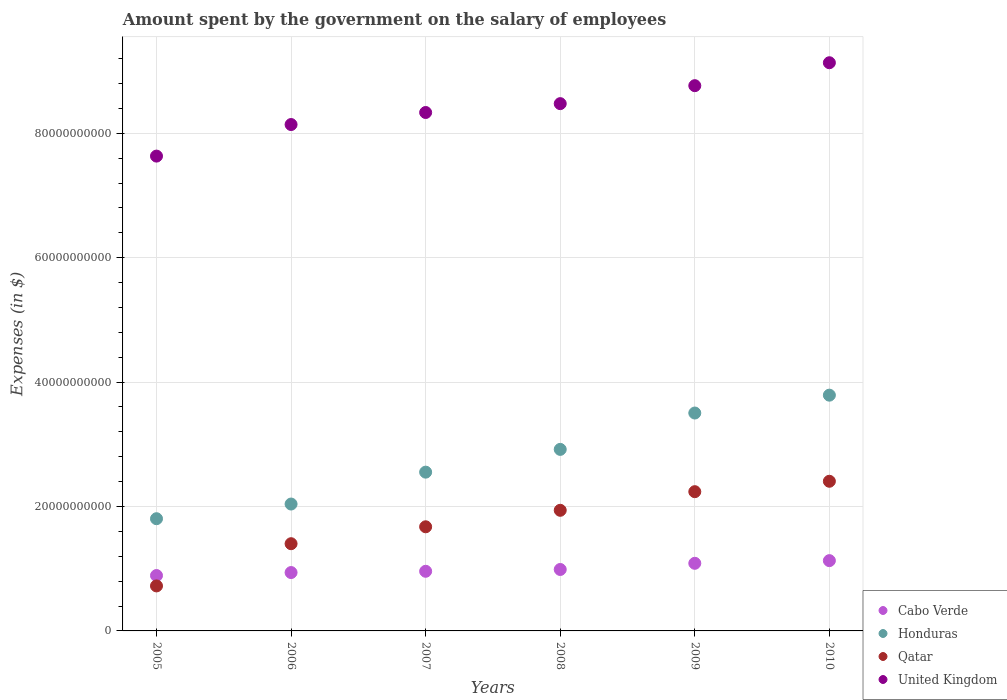How many different coloured dotlines are there?
Give a very brief answer. 4. Is the number of dotlines equal to the number of legend labels?
Provide a succinct answer. Yes. What is the amount spent on the salary of employees by the government in Qatar in 2008?
Ensure brevity in your answer.  1.94e+1. Across all years, what is the maximum amount spent on the salary of employees by the government in Qatar?
Provide a succinct answer. 2.41e+1. Across all years, what is the minimum amount spent on the salary of employees by the government in Honduras?
Your response must be concise. 1.80e+1. What is the total amount spent on the salary of employees by the government in Qatar in the graph?
Provide a short and direct response. 1.04e+11. What is the difference between the amount spent on the salary of employees by the government in Qatar in 2009 and that in 2010?
Keep it short and to the point. -1.67e+09. What is the difference between the amount spent on the salary of employees by the government in United Kingdom in 2007 and the amount spent on the salary of employees by the government in Honduras in 2010?
Give a very brief answer. 4.54e+1. What is the average amount spent on the salary of employees by the government in Qatar per year?
Your response must be concise. 1.73e+1. In the year 2006, what is the difference between the amount spent on the salary of employees by the government in Honduras and amount spent on the salary of employees by the government in Qatar?
Ensure brevity in your answer.  6.38e+09. What is the ratio of the amount spent on the salary of employees by the government in Cabo Verde in 2006 to that in 2008?
Make the answer very short. 0.95. Is the difference between the amount spent on the salary of employees by the government in Honduras in 2005 and 2006 greater than the difference between the amount spent on the salary of employees by the government in Qatar in 2005 and 2006?
Provide a succinct answer. Yes. What is the difference between the highest and the second highest amount spent on the salary of employees by the government in Honduras?
Offer a very short reply. 2.87e+09. What is the difference between the highest and the lowest amount spent on the salary of employees by the government in Qatar?
Ensure brevity in your answer.  1.68e+1. Is it the case that in every year, the sum of the amount spent on the salary of employees by the government in Cabo Verde and amount spent on the salary of employees by the government in United Kingdom  is greater than the amount spent on the salary of employees by the government in Qatar?
Offer a terse response. Yes. Does the amount spent on the salary of employees by the government in Qatar monotonically increase over the years?
Your answer should be very brief. Yes. How many years are there in the graph?
Offer a very short reply. 6. Where does the legend appear in the graph?
Offer a very short reply. Bottom right. What is the title of the graph?
Your response must be concise. Amount spent by the government on the salary of employees. Does "World" appear as one of the legend labels in the graph?
Offer a very short reply. No. What is the label or title of the X-axis?
Provide a succinct answer. Years. What is the label or title of the Y-axis?
Provide a succinct answer. Expenses (in $). What is the Expenses (in $) in Cabo Verde in 2005?
Offer a very short reply. 8.90e+09. What is the Expenses (in $) of Honduras in 2005?
Your answer should be very brief. 1.80e+1. What is the Expenses (in $) in Qatar in 2005?
Your answer should be compact. 7.23e+09. What is the Expenses (in $) of United Kingdom in 2005?
Make the answer very short. 7.63e+1. What is the Expenses (in $) of Cabo Verde in 2006?
Provide a succinct answer. 9.38e+09. What is the Expenses (in $) of Honduras in 2006?
Provide a short and direct response. 2.04e+1. What is the Expenses (in $) in Qatar in 2006?
Make the answer very short. 1.40e+1. What is the Expenses (in $) of United Kingdom in 2006?
Provide a succinct answer. 8.14e+1. What is the Expenses (in $) in Cabo Verde in 2007?
Offer a terse response. 9.59e+09. What is the Expenses (in $) of Honduras in 2007?
Offer a terse response. 2.55e+1. What is the Expenses (in $) of Qatar in 2007?
Your answer should be compact. 1.67e+1. What is the Expenses (in $) in United Kingdom in 2007?
Keep it short and to the point. 8.33e+1. What is the Expenses (in $) of Cabo Verde in 2008?
Your answer should be compact. 9.88e+09. What is the Expenses (in $) of Honduras in 2008?
Provide a short and direct response. 2.92e+1. What is the Expenses (in $) in Qatar in 2008?
Your response must be concise. 1.94e+1. What is the Expenses (in $) of United Kingdom in 2008?
Give a very brief answer. 8.48e+1. What is the Expenses (in $) of Cabo Verde in 2009?
Keep it short and to the point. 1.09e+1. What is the Expenses (in $) of Honduras in 2009?
Your answer should be compact. 3.50e+1. What is the Expenses (in $) of Qatar in 2009?
Your answer should be compact. 2.24e+1. What is the Expenses (in $) in United Kingdom in 2009?
Your answer should be compact. 8.77e+1. What is the Expenses (in $) in Cabo Verde in 2010?
Provide a short and direct response. 1.13e+1. What is the Expenses (in $) of Honduras in 2010?
Your response must be concise. 3.79e+1. What is the Expenses (in $) of Qatar in 2010?
Your answer should be very brief. 2.41e+1. What is the Expenses (in $) of United Kingdom in 2010?
Make the answer very short. 9.13e+1. Across all years, what is the maximum Expenses (in $) of Cabo Verde?
Keep it short and to the point. 1.13e+1. Across all years, what is the maximum Expenses (in $) of Honduras?
Give a very brief answer. 3.79e+1. Across all years, what is the maximum Expenses (in $) of Qatar?
Provide a short and direct response. 2.41e+1. Across all years, what is the maximum Expenses (in $) of United Kingdom?
Keep it short and to the point. 9.13e+1. Across all years, what is the minimum Expenses (in $) of Cabo Verde?
Your response must be concise. 8.90e+09. Across all years, what is the minimum Expenses (in $) in Honduras?
Offer a very short reply. 1.80e+1. Across all years, what is the minimum Expenses (in $) of Qatar?
Make the answer very short. 7.23e+09. Across all years, what is the minimum Expenses (in $) in United Kingdom?
Make the answer very short. 7.63e+1. What is the total Expenses (in $) of Cabo Verde in the graph?
Provide a succinct answer. 5.99e+1. What is the total Expenses (in $) in Honduras in the graph?
Make the answer very short. 1.66e+11. What is the total Expenses (in $) in Qatar in the graph?
Offer a very short reply. 1.04e+11. What is the total Expenses (in $) in United Kingdom in the graph?
Keep it short and to the point. 5.05e+11. What is the difference between the Expenses (in $) in Cabo Verde in 2005 and that in 2006?
Provide a succinct answer. -4.81e+08. What is the difference between the Expenses (in $) of Honduras in 2005 and that in 2006?
Ensure brevity in your answer.  -2.36e+09. What is the difference between the Expenses (in $) in Qatar in 2005 and that in 2006?
Offer a terse response. -6.79e+09. What is the difference between the Expenses (in $) in United Kingdom in 2005 and that in 2006?
Provide a succinct answer. -5.07e+09. What is the difference between the Expenses (in $) of Cabo Verde in 2005 and that in 2007?
Keep it short and to the point. -6.84e+08. What is the difference between the Expenses (in $) in Honduras in 2005 and that in 2007?
Ensure brevity in your answer.  -7.49e+09. What is the difference between the Expenses (in $) of Qatar in 2005 and that in 2007?
Give a very brief answer. -9.51e+09. What is the difference between the Expenses (in $) of United Kingdom in 2005 and that in 2007?
Provide a short and direct response. -7.01e+09. What is the difference between the Expenses (in $) in Cabo Verde in 2005 and that in 2008?
Your answer should be very brief. -9.74e+08. What is the difference between the Expenses (in $) in Honduras in 2005 and that in 2008?
Ensure brevity in your answer.  -1.11e+1. What is the difference between the Expenses (in $) of Qatar in 2005 and that in 2008?
Provide a succinct answer. -1.22e+1. What is the difference between the Expenses (in $) in United Kingdom in 2005 and that in 2008?
Offer a terse response. -8.43e+09. What is the difference between the Expenses (in $) of Cabo Verde in 2005 and that in 2009?
Your answer should be very brief. -1.97e+09. What is the difference between the Expenses (in $) in Honduras in 2005 and that in 2009?
Provide a short and direct response. -1.70e+1. What is the difference between the Expenses (in $) of Qatar in 2005 and that in 2009?
Provide a short and direct response. -1.52e+1. What is the difference between the Expenses (in $) in United Kingdom in 2005 and that in 2009?
Offer a terse response. -1.13e+1. What is the difference between the Expenses (in $) of Cabo Verde in 2005 and that in 2010?
Offer a very short reply. -2.39e+09. What is the difference between the Expenses (in $) in Honduras in 2005 and that in 2010?
Keep it short and to the point. -1.99e+1. What is the difference between the Expenses (in $) in Qatar in 2005 and that in 2010?
Your answer should be very brief. -1.68e+1. What is the difference between the Expenses (in $) of United Kingdom in 2005 and that in 2010?
Offer a very short reply. -1.50e+1. What is the difference between the Expenses (in $) in Cabo Verde in 2006 and that in 2007?
Your answer should be compact. -2.03e+08. What is the difference between the Expenses (in $) in Honduras in 2006 and that in 2007?
Provide a short and direct response. -5.13e+09. What is the difference between the Expenses (in $) of Qatar in 2006 and that in 2007?
Offer a very short reply. -2.72e+09. What is the difference between the Expenses (in $) of United Kingdom in 2006 and that in 2007?
Your answer should be very brief. -1.94e+09. What is the difference between the Expenses (in $) of Cabo Verde in 2006 and that in 2008?
Your answer should be very brief. -4.93e+08. What is the difference between the Expenses (in $) of Honduras in 2006 and that in 2008?
Offer a very short reply. -8.79e+09. What is the difference between the Expenses (in $) of Qatar in 2006 and that in 2008?
Give a very brief answer. -5.37e+09. What is the difference between the Expenses (in $) of United Kingdom in 2006 and that in 2008?
Provide a succinct answer. -3.36e+09. What is the difference between the Expenses (in $) in Cabo Verde in 2006 and that in 2009?
Your response must be concise. -1.49e+09. What is the difference between the Expenses (in $) in Honduras in 2006 and that in 2009?
Your answer should be very brief. -1.46e+1. What is the difference between the Expenses (in $) of Qatar in 2006 and that in 2009?
Ensure brevity in your answer.  -8.36e+09. What is the difference between the Expenses (in $) in United Kingdom in 2006 and that in 2009?
Give a very brief answer. -6.25e+09. What is the difference between the Expenses (in $) in Cabo Verde in 2006 and that in 2010?
Provide a succinct answer. -1.91e+09. What is the difference between the Expenses (in $) in Honduras in 2006 and that in 2010?
Provide a short and direct response. -1.75e+1. What is the difference between the Expenses (in $) in Qatar in 2006 and that in 2010?
Your answer should be very brief. -1.00e+1. What is the difference between the Expenses (in $) of United Kingdom in 2006 and that in 2010?
Make the answer very short. -9.94e+09. What is the difference between the Expenses (in $) of Cabo Verde in 2007 and that in 2008?
Offer a very short reply. -2.90e+08. What is the difference between the Expenses (in $) in Honduras in 2007 and that in 2008?
Provide a short and direct response. -3.66e+09. What is the difference between the Expenses (in $) of Qatar in 2007 and that in 2008?
Your answer should be very brief. -2.65e+09. What is the difference between the Expenses (in $) of United Kingdom in 2007 and that in 2008?
Provide a succinct answer. -1.42e+09. What is the difference between the Expenses (in $) of Cabo Verde in 2007 and that in 2009?
Give a very brief answer. -1.28e+09. What is the difference between the Expenses (in $) in Honduras in 2007 and that in 2009?
Provide a short and direct response. -9.50e+09. What is the difference between the Expenses (in $) of Qatar in 2007 and that in 2009?
Make the answer very short. -5.64e+09. What is the difference between the Expenses (in $) of United Kingdom in 2007 and that in 2009?
Your answer should be very brief. -4.31e+09. What is the difference between the Expenses (in $) in Cabo Verde in 2007 and that in 2010?
Your response must be concise. -1.71e+09. What is the difference between the Expenses (in $) in Honduras in 2007 and that in 2010?
Offer a very short reply. -1.24e+1. What is the difference between the Expenses (in $) in Qatar in 2007 and that in 2010?
Provide a short and direct response. -7.32e+09. What is the difference between the Expenses (in $) in United Kingdom in 2007 and that in 2010?
Your response must be concise. -8.00e+09. What is the difference between the Expenses (in $) in Cabo Verde in 2008 and that in 2009?
Give a very brief answer. -9.92e+08. What is the difference between the Expenses (in $) in Honduras in 2008 and that in 2009?
Give a very brief answer. -5.85e+09. What is the difference between the Expenses (in $) in Qatar in 2008 and that in 2009?
Provide a short and direct response. -2.99e+09. What is the difference between the Expenses (in $) in United Kingdom in 2008 and that in 2009?
Your response must be concise. -2.89e+09. What is the difference between the Expenses (in $) in Cabo Verde in 2008 and that in 2010?
Keep it short and to the point. -1.42e+09. What is the difference between the Expenses (in $) in Honduras in 2008 and that in 2010?
Your answer should be compact. -8.72e+09. What is the difference between the Expenses (in $) in Qatar in 2008 and that in 2010?
Ensure brevity in your answer.  -4.67e+09. What is the difference between the Expenses (in $) of United Kingdom in 2008 and that in 2010?
Your response must be concise. -6.58e+09. What is the difference between the Expenses (in $) of Cabo Verde in 2009 and that in 2010?
Provide a short and direct response. -4.29e+08. What is the difference between the Expenses (in $) of Honduras in 2009 and that in 2010?
Offer a very short reply. -2.87e+09. What is the difference between the Expenses (in $) of Qatar in 2009 and that in 2010?
Your response must be concise. -1.67e+09. What is the difference between the Expenses (in $) of United Kingdom in 2009 and that in 2010?
Give a very brief answer. -3.69e+09. What is the difference between the Expenses (in $) in Cabo Verde in 2005 and the Expenses (in $) in Honduras in 2006?
Make the answer very short. -1.15e+1. What is the difference between the Expenses (in $) in Cabo Verde in 2005 and the Expenses (in $) in Qatar in 2006?
Your response must be concise. -5.12e+09. What is the difference between the Expenses (in $) in Cabo Verde in 2005 and the Expenses (in $) in United Kingdom in 2006?
Provide a succinct answer. -7.25e+1. What is the difference between the Expenses (in $) of Honduras in 2005 and the Expenses (in $) of Qatar in 2006?
Provide a succinct answer. 4.02e+09. What is the difference between the Expenses (in $) of Honduras in 2005 and the Expenses (in $) of United Kingdom in 2006?
Offer a terse response. -6.34e+1. What is the difference between the Expenses (in $) of Qatar in 2005 and the Expenses (in $) of United Kingdom in 2006?
Make the answer very short. -7.42e+1. What is the difference between the Expenses (in $) in Cabo Verde in 2005 and the Expenses (in $) in Honduras in 2007?
Ensure brevity in your answer.  -1.66e+1. What is the difference between the Expenses (in $) of Cabo Verde in 2005 and the Expenses (in $) of Qatar in 2007?
Ensure brevity in your answer.  -7.84e+09. What is the difference between the Expenses (in $) in Cabo Verde in 2005 and the Expenses (in $) in United Kingdom in 2007?
Give a very brief answer. -7.44e+1. What is the difference between the Expenses (in $) in Honduras in 2005 and the Expenses (in $) in Qatar in 2007?
Offer a very short reply. 1.30e+09. What is the difference between the Expenses (in $) in Honduras in 2005 and the Expenses (in $) in United Kingdom in 2007?
Offer a terse response. -6.53e+1. What is the difference between the Expenses (in $) in Qatar in 2005 and the Expenses (in $) in United Kingdom in 2007?
Provide a succinct answer. -7.61e+1. What is the difference between the Expenses (in $) in Cabo Verde in 2005 and the Expenses (in $) in Honduras in 2008?
Provide a short and direct response. -2.03e+1. What is the difference between the Expenses (in $) in Cabo Verde in 2005 and the Expenses (in $) in Qatar in 2008?
Keep it short and to the point. -1.05e+1. What is the difference between the Expenses (in $) of Cabo Verde in 2005 and the Expenses (in $) of United Kingdom in 2008?
Give a very brief answer. -7.59e+1. What is the difference between the Expenses (in $) in Honduras in 2005 and the Expenses (in $) in Qatar in 2008?
Offer a very short reply. -1.35e+09. What is the difference between the Expenses (in $) in Honduras in 2005 and the Expenses (in $) in United Kingdom in 2008?
Your answer should be very brief. -6.67e+1. What is the difference between the Expenses (in $) of Qatar in 2005 and the Expenses (in $) of United Kingdom in 2008?
Make the answer very short. -7.75e+1. What is the difference between the Expenses (in $) in Cabo Verde in 2005 and the Expenses (in $) in Honduras in 2009?
Provide a succinct answer. -2.61e+1. What is the difference between the Expenses (in $) in Cabo Verde in 2005 and the Expenses (in $) in Qatar in 2009?
Your response must be concise. -1.35e+1. What is the difference between the Expenses (in $) of Cabo Verde in 2005 and the Expenses (in $) of United Kingdom in 2009?
Your response must be concise. -7.87e+1. What is the difference between the Expenses (in $) in Honduras in 2005 and the Expenses (in $) in Qatar in 2009?
Your answer should be compact. -4.35e+09. What is the difference between the Expenses (in $) of Honduras in 2005 and the Expenses (in $) of United Kingdom in 2009?
Your answer should be very brief. -6.96e+1. What is the difference between the Expenses (in $) of Qatar in 2005 and the Expenses (in $) of United Kingdom in 2009?
Keep it short and to the point. -8.04e+1. What is the difference between the Expenses (in $) of Cabo Verde in 2005 and the Expenses (in $) of Honduras in 2010?
Your answer should be compact. -2.90e+1. What is the difference between the Expenses (in $) of Cabo Verde in 2005 and the Expenses (in $) of Qatar in 2010?
Offer a very short reply. -1.52e+1. What is the difference between the Expenses (in $) in Cabo Verde in 2005 and the Expenses (in $) in United Kingdom in 2010?
Your response must be concise. -8.24e+1. What is the difference between the Expenses (in $) of Honduras in 2005 and the Expenses (in $) of Qatar in 2010?
Your answer should be very brief. -6.02e+09. What is the difference between the Expenses (in $) in Honduras in 2005 and the Expenses (in $) in United Kingdom in 2010?
Offer a terse response. -7.33e+1. What is the difference between the Expenses (in $) of Qatar in 2005 and the Expenses (in $) of United Kingdom in 2010?
Your answer should be compact. -8.41e+1. What is the difference between the Expenses (in $) in Cabo Verde in 2006 and the Expenses (in $) in Honduras in 2007?
Your response must be concise. -1.61e+1. What is the difference between the Expenses (in $) in Cabo Verde in 2006 and the Expenses (in $) in Qatar in 2007?
Offer a terse response. -7.36e+09. What is the difference between the Expenses (in $) of Cabo Verde in 2006 and the Expenses (in $) of United Kingdom in 2007?
Provide a short and direct response. -7.40e+1. What is the difference between the Expenses (in $) in Honduras in 2006 and the Expenses (in $) in Qatar in 2007?
Your answer should be compact. 3.66e+09. What is the difference between the Expenses (in $) of Honduras in 2006 and the Expenses (in $) of United Kingdom in 2007?
Make the answer very short. -6.29e+1. What is the difference between the Expenses (in $) of Qatar in 2006 and the Expenses (in $) of United Kingdom in 2007?
Ensure brevity in your answer.  -6.93e+1. What is the difference between the Expenses (in $) in Cabo Verde in 2006 and the Expenses (in $) in Honduras in 2008?
Your answer should be compact. -1.98e+1. What is the difference between the Expenses (in $) in Cabo Verde in 2006 and the Expenses (in $) in Qatar in 2008?
Offer a terse response. -1.00e+1. What is the difference between the Expenses (in $) of Cabo Verde in 2006 and the Expenses (in $) of United Kingdom in 2008?
Your answer should be very brief. -7.54e+1. What is the difference between the Expenses (in $) of Honduras in 2006 and the Expenses (in $) of Qatar in 2008?
Make the answer very short. 1.01e+09. What is the difference between the Expenses (in $) of Honduras in 2006 and the Expenses (in $) of United Kingdom in 2008?
Your response must be concise. -6.44e+1. What is the difference between the Expenses (in $) in Qatar in 2006 and the Expenses (in $) in United Kingdom in 2008?
Give a very brief answer. -7.07e+1. What is the difference between the Expenses (in $) in Cabo Verde in 2006 and the Expenses (in $) in Honduras in 2009?
Make the answer very short. -2.56e+1. What is the difference between the Expenses (in $) of Cabo Verde in 2006 and the Expenses (in $) of Qatar in 2009?
Your response must be concise. -1.30e+1. What is the difference between the Expenses (in $) in Cabo Verde in 2006 and the Expenses (in $) in United Kingdom in 2009?
Provide a short and direct response. -7.83e+1. What is the difference between the Expenses (in $) in Honduras in 2006 and the Expenses (in $) in Qatar in 2009?
Give a very brief answer. -1.99e+09. What is the difference between the Expenses (in $) in Honduras in 2006 and the Expenses (in $) in United Kingdom in 2009?
Offer a terse response. -6.73e+1. What is the difference between the Expenses (in $) of Qatar in 2006 and the Expenses (in $) of United Kingdom in 2009?
Ensure brevity in your answer.  -7.36e+1. What is the difference between the Expenses (in $) of Cabo Verde in 2006 and the Expenses (in $) of Honduras in 2010?
Your answer should be compact. -2.85e+1. What is the difference between the Expenses (in $) of Cabo Verde in 2006 and the Expenses (in $) of Qatar in 2010?
Your answer should be compact. -1.47e+1. What is the difference between the Expenses (in $) of Cabo Verde in 2006 and the Expenses (in $) of United Kingdom in 2010?
Keep it short and to the point. -8.20e+1. What is the difference between the Expenses (in $) in Honduras in 2006 and the Expenses (in $) in Qatar in 2010?
Provide a short and direct response. -3.66e+09. What is the difference between the Expenses (in $) of Honduras in 2006 and the Expenses (in $) of United Kingdom in 2010?
Offer a terse response. -7.09e+1. What is the difference between the Expenses (in $) of Qatar in 2006 and the Expenses (in $) of United Kingdom in 2010?
Your answer should be compact. -7.73e+1. What is the difference between the Expenses (in $) of Cabo Verde in 2007 and the Expenses (in $) of Honduras in 2008?
Keep it short and to the point. -1.96e+1. What is the difference between the Expenses (in $) of Cabo Verde in 2007 and the Expenses (in $) of Qatar in 2008?
Provide a succinct answer. -9.80e+09. What is the difference between the Expenses (in $) in Cabo Verde in 2007 and the Expenses (in $) in United Kingdom in 2008?
Ensure brevity in your answer.  -7.52e+1. What is the difference between the Expenses (in $) in Honduras in 2007 and the Expenses (in $) in Qatar in 2008?
Provide a short and direct response. 6.13e+09. What is the difference between the Expenses (in $) in Honduras in 2007 and the Expenses (in $) in United Kingdom in 2008?
Keep it short and to the point. -5.92e+1. What is the difference between the Expenses (in $) of Qatar in 2007 and the Expenses (in $) of United Kingdom in 2008?
Your response must be concise. -6.80e+1. What is the difference between the Expenses (in $) of Cabo Verde in 2007 and the Expenses (in $) of Honduras in 2009?
Provide a short and direct response. -2.54e+1. What is the difference between the Expenses (in $) in Cabo Verde in 2007 and the Expenses (in $) in Qatar in 2009?
Your answer should be compact. -1.28e+1. What is the difference between the Expenses (in $) in Cabo Verde in 2007 and the Expenses (in $) in United Kingdom in 2009?
Keep it short and to the point. -7.81e+1. What is the difference between the Expenses (in $) of Honduras in 2007 and the Expenses (in $) of Qatar in 2009?
Keep it short and to the point. 3.14e+09. What is the difference between the Expenses (in $) in Honduras in 2007 and the Expenses (in $) in United Kingdom in 2009?
Keep it short and to the point. -6.21e+1. What is the difference between the Expenses (in $) in Qatar in 2007 and the Expenses (in $) in United Kingdom in 2009?
Your response must be concise. -7.09e+1. What is the difference between the Expenses (in $) of Cabo Verde in 2007 and the Expenses (in $) of Honduras in 2010?
Give a very brief answer. -2.83e+1. What is the difference between the Expenses (in $) of Cabo Verde in 2007 and the Expenses (in $) of Qatar in 2010?
Give a very brief answer. -1.45e+1. What is the difference between the Expenses (in $) in Cabo Verde in 2007 and the Expenses (in $) in United Kingdom in 2010?
Offer a terse response. -8.18e+1. What is the difference between the Expenses (in $) in Honduras in 2007 and the Expenses (in $) in Qatar in 2010?
Offer a very short reply. 1.47e+09. What is the difference between the Expenses (in $) in Honduras in 2007 and the Expenses (in $) in United Kingdom in 2010?
Your response must be concise. -6.58e+1. What is the difference between the Expenses (in $) in Qatar in 2007 and the Expenses (in $) in United Kingdom in 2010?
Your answer should be compact. -7.46e+1. What is the difference between the Expenses (in $) of Cabo Verde in 2008 and the Expenses (in $) of Honduras in 2009?
Your answer should be very brief. -2.52e+1. What is the difference between the Expenses (in $) in Cabo Verde in 2008 and the Expenses (in $) in Qatar in 2009?
Your answer should be very brief. -1.25e+1. What is the difference between the Expenses (in $) in Cabo Verde in 2008 and the Expenses (in $) in United Kingdom in 2009?
Give a very brief answer. -7.78e+1. What is the difference between the Expenses (in $) of Honduras in 2008 and the Expenses (in $) of Qatar in 2009?
Offer a terse response. 6.80e+09. What is the difference between the Expenses (in $) of Honduras in 2008 and the Expenses (in $) of United Kingdom in 2009?
Offer a terse response. -5.85e+1. What is the difference between the Expenses (in $) in Qatar in 2008 and the Expenses (in $) in United Kingdom in 2009?
Your answer should be very brief. -6.83e+1. What is the difference between the Expenses (in $) of Cabo Verde in 2008 and the Expenses (in $) of Honduras in 2010?
Keep it short and to the point. -2.80e+1. What is the difference between the Expenses (in $) of Cabo Verde in 2008 and the Expenses (in $) of Qatar in 2010?
Provide a succinct answer. -1.42e+1. What is the difference between the Expenses (in $) in Cabo Verde in 2008 and the Expenses (in $) in United Kingdom in 2010?
Offer a very short reply. -8.15e+1. What is the difference between the Expenses (in $) of Honduras in 2008 and the Expenses (in $) of Qatar in 2010?
Your answer should be very brief. 5.12e+09. What is the difference between the Expenses (in $) in Honduras in 2008 and the Expenses (in $) in United Kingdom in 2010?
Make the answer very short. -6.22e+1. What is the difference between the Expenses (in $) in Qatar in 2008 and the Expenses (in $) in United Kingdom in 2010?
Your answer should be very brief. -7.19e+1. What is the difference between the Expenses (in $) of Cabo Verde in 2009 and the Expenses (in $) of Honduras in 2010?
Ensure brevity in your answer.  -2.70e+1. What is the difference between the Expenses (in $) in Cabo Verde in 2009 and the Expenses (in $) in Qatar in 2010?
Keep it short and to the point. -1.32e+1. What is the difference between the Expenses (in $) of Cabo Verde in 2009 and the Expenses (in $) of United Kingdom in 2010?
Provide a succinct answer. -8.05e+1. What is the difference between the Expenses (in $) in Honduras in 2009 and the Expenses (in $) in Qatar in 2010?
Provide a succinct answer. 1.10e+1. What is the difference between the Expenses (in $) of Honduras in 2009 and the Expenses (in $) of United Kingdom in 2010?
Offer a terse response. -5.63e+1. What is the difference between the Expenses (in $) of Qatar in 2009 and the Expenses (in $) of United Kingdom in 2010?
Provide a short and direct response. -6.90e+1. What is the average Expenses (in $) in Cabo Verde per year?
Your answer should be compact. 9.99e+09. What is the average Expenses (in $) in Honduras per year?
Offer a terse response. 2.77e+1. What is the average Expenses (in $) of Qatar per year?
Your response must be concise. 1.73e+1. What is the average Expenses (in $) of United Kingdom per year?
Make the answer very short. 8.41e+1. In the year 2005, what is the difference between the Expenses (in $) of Cabo Verde and Expenses (in $) of Honduras?
Give a very brief answer. -9.13e+09. In the year 2005, what is the difference between the Expenses (in $) in Cabo Verde and Expenses (in $) in Qatar?
Provide a short and direct response. 1.67e+09. In the year 2005, what is the difference between the Expenses (in $) of Cabo Verde and Expenses (in $) of United Kingdom?
Make the answer very short. -6.74e+1. In the year 2005, what is the difference between the Expenses (in $) of Honduras and Expenses (in $) of Qatar?
Offer a terse response. 1.08e+1. In the year 2005, what is the difference between the Expenses (in $) of Honduras and Expenses (in $) of United Kingdom?
Provide a short and direct response. -5.83e+1. In the year 2005, what is the difference between the Expenses (in $) in Qatar and Expenses (in $) in United Kingdom?
Provide a succinct answer. -6.91e+1. In the year 2006, what is the difference between the Expenses (in $) in Cabo Verde and Expenses (in $) in Honduras?
Provide a short and direct response. -1.10e+1. In the year 2006, what is the difference between the Expenses (in $) of Cabo Verde and Expenses (in $) of Qatar?
Ensure brevity in your answer.  -4.64e+09. In the year 2006, what is the difference between the Expenses (in $) in Cabo Verde and Expenses (in $) in United Kingdom?
Ensure brevity in your answer.  -7.20e+1. In the year 2006, what is the difference between the Expenses (in $) in Honduras and Expenses (in $) in Qatar?
Provide a succinct answer. 6.38e+09. In the year 2006, what is the difference between the Expenses (in $) in Honduras and Expenses (in $) in United Kingdom?
Your answer should be very brief. -6.10e+1. In the year 2006, what is the difference between the Expenses (in $) in Qatar and Expenses (in $) in United Kingdom?
Ensure brevity in your answer.  -6.74e+1. In the year 2007, what is the difference between the Expenses (in $) in Cabo Verde and Expenses (in $) in Honduras?
Provide a short and direct response. -1.59e+1. In the year 2007, what is the difference between the Expenses (in $) of Cabo Verde and Expenses (in $) of Qatar?
Offer a terse response. -7.15e+09. In the year 2007, what is the difference between the Expenses (in $) in Cabo Verde and Expenses (in $) in United Kingdom?
Give a very brief answer. -7.38e+1. In the year 2007, what is the difference between the Expenses (in $) of Honduras and Expenses (in $) of Qatar?
Your response must be concise. 8.78e+09. In the year 2007, what is the difference between the Expenses (in $) in Honduras and Expenses (in $) in United Kingdom?
Make the answer very short. -5.78e+1. In the year 2007, what is the difference between the Expenses (in $) of Qatar and Expenses (in $) of United Kingdom?
Your answer should be compact. -6.66e+1. In the year 2008, what is the difference between the Expenses (in $) of Cabo Verde and Expenses (in $) of Honduras?
Your response must be concise. -1.93e+1. In the year 2008, what is the difference between the Expenses (in $) in Cabo Verde and Expenses (in $) in Qatar?
Provide a succinct answer. -9.51e+09. In the year 2008, what is the difference between the Expenses (in $) of Cabo Verde and Expenses (in $) of United Kingdom?
Keep it short and to the point. -7.49e+1. In the year 2008, what is the difference between the Expenses (in $) of Honduras and Expenses (in $) of Qatar?
Your answer should be compact. 9.79e+09. In the year 2008, what is the difference between the Expenses (in $) of Honduras and Expenses (in $) of United Kingdom?
Give a very brief answer. -5.56e+1. In the year 2008, what is the difference between the Expenses (in $) in Qatar and Expenses (in $) in United Kingdom?
Your answer should be very brief. -6.54e+1. In the year 2009, what is the difference between the Expenses (in $) of Cabo Verde and Expenses (in $) of Honduras?
Offer a terse response. -2.42e+1. In the year 2009, what is the difference between the Expenses (in $) in Cabo Verde and Expenses (in $) in Qatar?
Offer a very short reply. -1.15e+1. In the year 2009, what is the difference between the Expenses (in $) of Cabo Verde and Expenses (in $) of United Kingdom?
Keep it short and to the point. -7.68e+1. In the year 2009, what is the difference between the Expenses (in $) in Honduras and Expenses (in $) in Qatar?
Make the answer very short. 1.26e+1. In the year 2009, what is the difference between the Expenses (in $) of Honduras and Expenses (in $) of United Kingdom?
Keep it short and to the point. -5.26e+1. In the year 2009, what is the difference between the Expenses (in $) in Qatar and Expenses (in $) in United Kingdom?
Keep it short and to the point. -6.53e+1. In the year 2010, what is the difference between the Expenses (in $) in Cabo Verde and Expenses (in $) in Honduras?
Provide a short and direct response. -2.66e+1. In the year 2010, what is the difference between the Expenses (in $) in Cabo Verde and Expenses (in $) in Qatar?
Make the answer very short. -1.28e+1. In the year 2010, what is the difference between the Expenses (in $) of Cabo Verde and Expenses (in $) of United Kingdom?
Keep it short and to the point. -8.00e+1. In the year 2010, what is the difference between the Expenses (in $) in Honduras and Expenses (in $) in Qatar?
Offer a terse response. 1.38e+1. In the year 2010, what is the difference between the Expenses (in $) of Honduras and Expenses (in $) of United Kingdom?
Provide a short and direct response. -5.34e+1. In the year 2010, what is the difference between the Expenses (in $) of Qatar and Expenses (in $) of United Kingdom?
Your answer should be very brief. -6.73e+1. What is the ratio of the Expenses (in $) of Cabo Verde in 2005 to that in 2006?
Provide a succinct answer. 0.95. What is the ratio of the Expenses (in $) in Honduras in 2005 to that in 2006?
Give a very brief answer. 0.88. What is the ratio of the Expenses (in $) in Qatar in 2005 to that in 2006?
Provide a succinct answer. 0.52. What is the ratio of the Expenses (in $) of United Kingdom in 2005 to that in 2006?
Make the answer very short. 0.94. What is the ratio of the Expenses (in $) in Cabo Verde in 2005 to that in 2007?
Provide a succinct answer. 0.93. What is the ratio of the Expenses (in $) in Honduras in 2005 to that in 2007?
Offer a very short reply. 0.71. What is the ratio of the Expenses (in $) in Qatar in 2005 to that in 2007?
Make the answer very short. 0.43. What is the ratio of the Expenses (in $) in United Kingdom in 2005 to that in 2007?
Keep it short and to the point. 0.92. What is the ratio of the Expenses (in $) of Cabo Verde in 2005 to that in 2008?
Provide a short and direct response. 0.9. What is the ratio of the Expenses (in $) in Honduras in 2005 to that in 2008?
Keep it short and to the point. 0.62. What is the ratio of the Expenses (in $) of Qatar in 2005 to that in 2008?
Your answer should be compact. 0.37. What is the ratio of the Expenses (in $) in United Kingdom in 2005 to that in 2008?
Ensure brevity in your answer.  0.9. What is the ratio of the Expenses (in $) in Cabo Verde in 2005 to that in 2009?
Ensure brevity in your answer.  0.82. What is the ratio of the Expenses (in $) in Honduras in 2005 to that in 2009?
Ensure brevity in your answer.  0.52. What is the ratio of the Expenses (in $) in Qatar in 2005 to that in 2009?
Make the answer very short. 0.32. What is the ratio of the Expenses (in $) in United Kingdom in 2005 to that in 2009?
Provide a succinct answer. 0.87. What is the ratio of the Expenses (in $) in Cabo Verde in 2005 to that in 2010?
Provide a succinct answer. 0.79. What is the ratio of the Expenses (in $) of Honduras in 2005 to that in 2010?
Provide a succinct answer. 0.48. What is the ratio of the Expenses (in $) in Qatar in 2005 to that in 2010?
Give a very brief answer. 0.3. What is the ratio of the Expenses (in $) of United Kingdom in 2005 to that in 2010?
Make the answer very short. 0.84. What is the ratio of the Expenses (in $) of Cabo Verde in 2006 to that in 2007?
Give a very brief answer. 0.98. What is the ratio of the Expenses (in $) of Honduras in 2006 to that in 2007?
Your answer should be very brief. 0.8. What is the ratio of the Expenses (in $) in Qatar in 2006 to that in 2007?
Give a very brief answer. 0.84. What is the ratio of the Expenses (in $) in United Kingdom in 2006 to that in 2007?
Provide a succinct answer. 0.98. What is the ratio of the Expenses (in $) in Cabo Verde in 2006 to that in 2008?
Offer a very short reply. 0.95. What is the ratio of the Expenses (in $) of Honduras in 2006 to that in 2008?
Make the answer very short. 0.7. What is the ratio of the Expenses (in $) of Qatar in 2006 to that in 2008?
Your answer should be very brief. 0.72. What is the ratio of the Expenses (in $) of United Kingdom in 2006 to that in 2008?
Ensure brevity in your answer.  0.96. What is the ratio of the Expenses (in $) of Cabo Verde in 2006 to that in 2009?
Provide a succinct answer. 0.86. What is the ratio of the Expenses (in $) of Honduras in 2006 to that in 2009?
Make the answer very short. 0.58. What is the ratio of the Expenses (in $) in Qatar in 2006 to that in 2009?
Your answer should be very brief. 0.63. What is the ratio of the Expenses (in $) of United Kingdom in 2006 to that in 2009?
Give a very brief answer. 0.93. What is the ratio of the Expenses (in $) in Cabo Verde in 2006 to that in 2010?
Provide a short and direct response. 0.83. What is the ratio of the Expenses (in $) of Honduras in 2006 to that in 2010?
Your answer should be very brief. 0.54. What is the ratio of the Expenses (in $) in Qatar in 2006 to that in 2010?
Ensure brevity in your answer.  0.58. What is the ratio of the Expenses (in $) of United Kingdom in 2006 to that in 2010?
Give a very brief answer. 0.89. What is the ratio of the Expenses (in $) in Cabo Verde in 2007 to that in 2008?
Keep it short and to the point. 0.97. What is the ratio of the Expenses (in $) of Honduras in 2007 to that in 2008?
Offer a very short reply. 0.87. What is the ratio of the Expenses (in $) of Qatar in 2007 to that in 2008?
Your response must be concise. 0.86. What is the ratio of the Expenses (in $) of United Kingdom in 2007 to that in 2008?
Provide a short and direct response. 0.98. What is the ratio of the Expenses (in $) in Cabo Verde in 2007 to that in 2009?
Make the answer very short. 0.88. What is the ratio of the Expenses (in $) of Honduras in 2007 to that in 2009?
Your answer should be compact. 0.73. What is the ratio of the Expenses (in $) in Qatar in 2007 to that in 2009?
Your answer should be compact. 0.75. What is the ratio of the Expenses (in $) of United Kingdom in 2007 to that in 2009?
Provide a succinct answer. 0.95. What is the ratio of the Expenses (in $) of Cabo Verde in 2007 to that in 2010?
Offer a terse response. 0.85. What is the ratio of the Expenses (in $) in Honduras in 2007 to that in 2010?
Your answer should be very brief. 0.67. What is the ratio of the Expenses (in $) in Qatar in 2007 to that in 2010?
Your response must be concise. 0.7. What is the ratio of the Expenses (in $) of United Kingdom in 2007 to that in 2010?
Offer a terse response. 0.91. What is the ratio of the Expenses (in $) of Cabo Verde in 2008 to that in 2009?
Provide a succinct answer. 0.91. What is the ratio of the Expenses (in $) of Honduras in 2008 to that in 2009?
Keep it short and to the point. 0.83. What is the ratio of the Expenses (in $) in Qatar in 2008 to that in 2009?
Make the answer very short. 0.87. What is the ratio of the Expenses (in $) of Cabo Verde in 2008 to that in 2010?
Make the answer very short. 0.87. What is the ratio of the Expenses (in $) of Honduras in 2008 to that in 2010?
Ensure brevity in your answer.  0.77. What is the ratio of the Expenses (in $) in Qatar in 2008 to that in 2010?
Keep it short and to the point. 0.81. What is the ratio of the Expenses (in $) of United Kingdom in 2008 to that in 2010?
Your answer should be compact. 0.93. What is the ratio of the Expenses (in $) in Honduras in 2009 to that in 2010?
Your answer should be very brief. 0.92. What is the ratio of the Expenses (in $) in Qatar in 2009 to that in 2010?
Offer a very short reply. 0.93. What is the ratio of the Expenses (in $) of United Kingdom in 2009 to that in 2010?
Your answer should be compact. 0.96. What is the difference between the highest and the second highest Expenses (in $) of Cabo Verde?
Provide a succinct answer. 4.29e+08. What is the difference between the highest and the second highest Expenses (in $) in Honduras?
Keep it short and to the point. 2.87e+09. What is the difference between the highest and the second highest Expenses (in $) in Qatar?
Offer a very short reply. 1.67e+09. What is the difference between the highest and the second highest Expenses (in $) of United Kingdom?
Ensure brevity in your answer.  3.69e+09. What is the difference between the highest and the lowest Expenses (in $) in Cabo Verde?
Your response must be concise. 2.39e+09. What is the difference between the highest and the lowest Expenses (in $) of Honduras?
Give a very brief answer. 1.99e+1. What is the difference between the highest and the lowest Expenses (in $) of Qatar?
Ensure brevity in your answer.  1.68e+1. What is the difference between the highest and the lowest Expenses (in $) in United Kingdom?
Keep it short and to the point. 1.50e+1. 